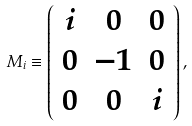Convert formula to latex. <formula><loc_0><loc_0><loc_500><loc_500>M _ { i } \equiv \left ( \begin{array} { c c c } i & 0 & 0 \\ 0 & - 1 & 0 \\ 0 & 0 & i \end{array} \right ) ,</formula> 